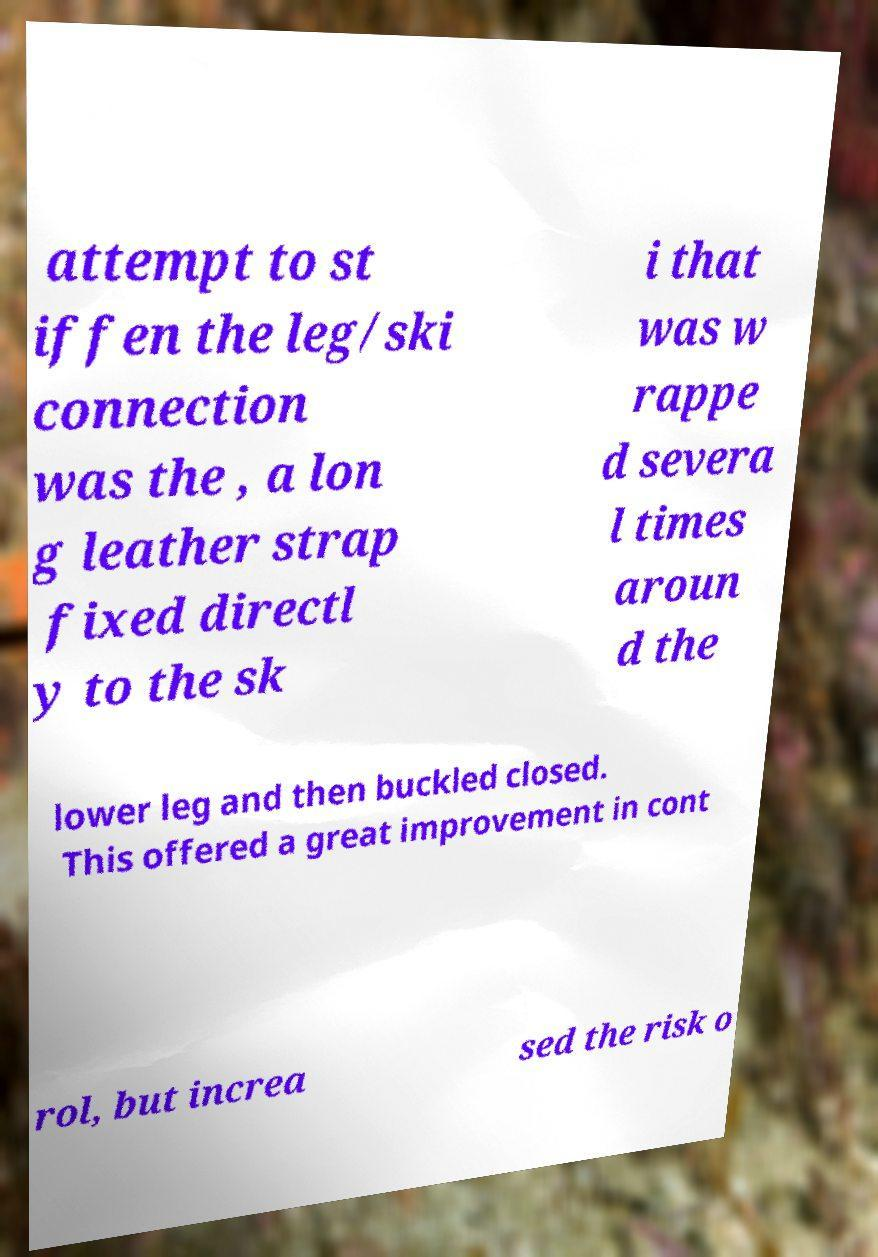Please identify and transcribe the text found in this image. attempt to st iffen the leg/ski connection was the , a lon g leather strap fixed directl y to the sk i that was w rappe d severa l times aroun d the lower leg and then buckled closed. This offered a great improvement in cont rol, but increa sed the risk o 